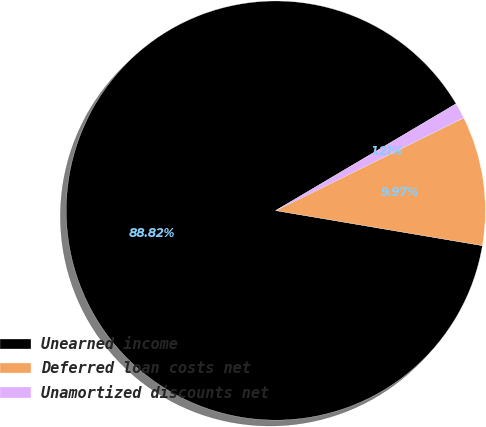Convert chart to OTSL. <chart><loc_0><loc_0><loc_500><loc_500><pie_chart><fcel>Unearned income<fcel>Deferred loan costs net<fcel>Unamortized discounts net<nl><fcel>88.82%<fcel>9.97%<fcel>1.21%<nl></chart> 